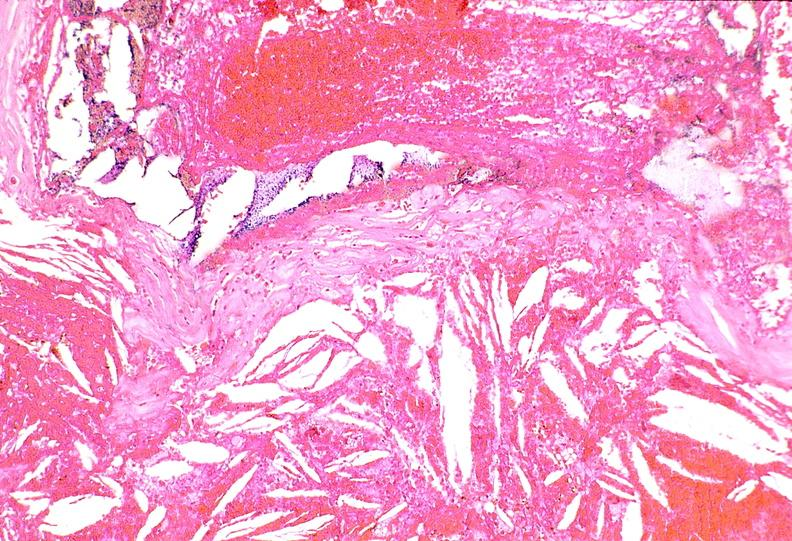what does this image show?
Answer the question using a single word or phrase. Right coronary artery 